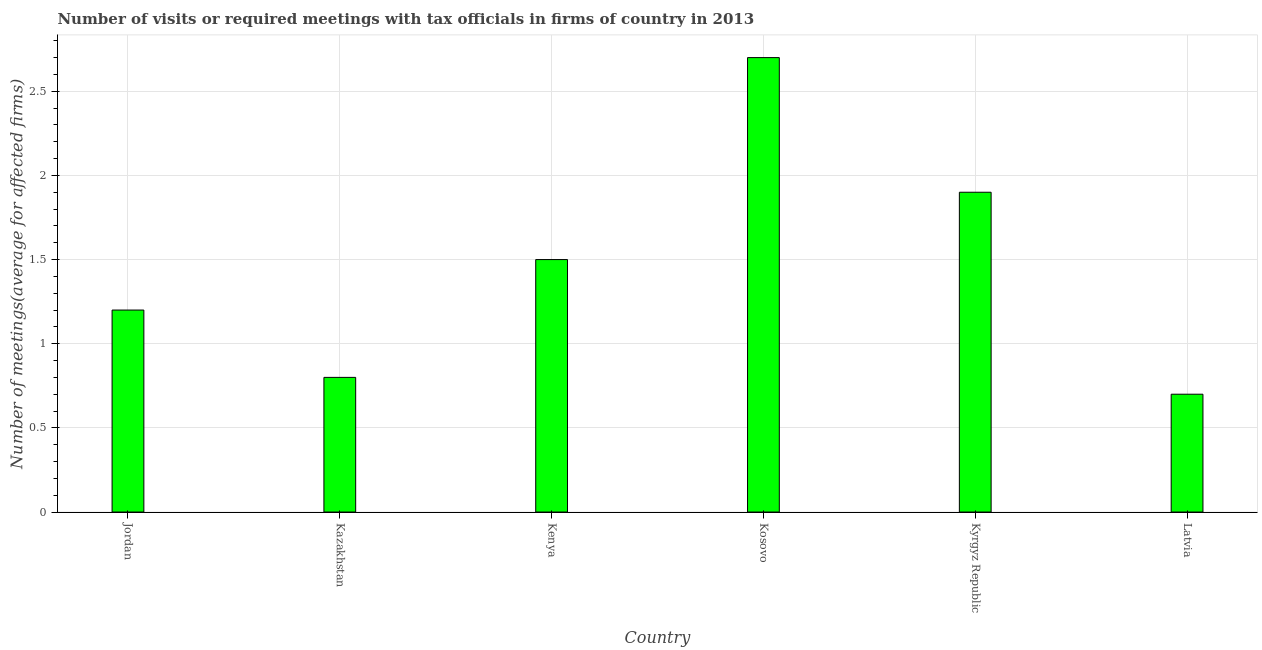Does the graph contain any zero values?
Offer a terse response. No. What is the title of the graph?
Make the answer very short. Number of visits or required meetings with tax officials in firms of country in 2013. What is the label or title of the Y-axis?
Provide a succinct answer. Number of meetings(average for affected firms). Across all countries, what is the maximum number of required meetings with tax officials?
Your answer should be very brief. 2.7. In which country was the number of required meetings with tax officials maximum?
Make the answer very short. Kosovo. In which country was the number of required meetings with tax officials minimum?
Provide a succinct answer. Latvia. What is the sum of the number of required meetings with tax officials?
Offer a very short reply. 8.8. What is the average number of required meetings with tax officials per country?
Your answer should be compact. 1.47. What is the median number of required meetings with tax officials?
Your response must be concise. 1.35. In how many countries, is the number of required meetings with tax officials greater than 0.6 ?
Make the answer very short. 6. What is the ratio of the number of required meetings with tax officials in Kazakhstan to that in Kenya?
Give a very brief answer. 0.53. What is the difference between the highest and the second highest number of required meetings with tax officials?
Provide a succinct answer. 0.8. What is the difference between the highest and the lowest number of required meetings with tax officials?
Your response must be concise. 2. Are all the bars in the graph horizontal?
Your answer should be compact. No. What is the difference between two consecutive major ticks on the Y-axis?
Offer a very short reply. 0.5. Are the values on the major ticks of Y-axis written in scientific E-notation?
Keep it short and to the point. No. What is the Number of meetings(average for affected firms) of Jordan?
Offer a terse response. 1.2. What is the Number of meetings(average for affected firms) of Kazakhstan?
Offer a terse response. 0.8. What is the Number of meetings(average for affected firms) in Kenya?
Your response must be concise. 1.5. What is the Number of meetings(average for affected firms) of Kosovo?
Your answer should be compact. 2.7. What is the Number of meetings(average for affected firms) in Kyrgyz Republic?
Offer a terse response. 1.9. What is the difference between the Number of meetings(average for affected firms) in Jordan and Kenya?
Your response must be concise. -0.3. What is the difference between the Number of meetings(average for affected firms) in Kazakhstan and Kyrgyz Republic?
Provide a short and direct response. -1.1. What is the difference between the Number of meetings(average for affected firms) in Kazakhstan and Latvia?
Your answer should be compact. 0.1. What is the difference between the Number of meetings(average for affected firms) in Kenya and Kosovo?
Ensure brevity in your answer.  -1.2. What is the difference between the Number of meetings(average for affected firms) in Kenya and Kyrgyz Republic?
Your answer should be compact. -0.4. What is the difference between the Number of meetings(average for affected firms) in Kenya and Latvia?
Your response must be concise. 0.8. What is the difference between the Number of meetings(average for affected firms) in Kosovo and Latvia?
Your answer should be compact. 2. What is the ratio of the Number of meetings(average for affected firms) in Jordan to that in Kenya?
Offer a very short reply. 0.8. What is the ratio of the Number of meetings(average for affected firms) in Jordan to that in Kosovo?
Provide a short and direct response. 0.44. What is the ratio of the Number of meetings(average for affected firms) in Jordan to that in Kyrgyz Republic?
Make the answer very short. 0.63. What is the ratio of the Number of meetings(average for affected firms) in Jordan to that in Latvia?
Your answer should be compact. 1.71. What is the ratio of the Number of meetings(average for affected firms) in Kazakhstan to that in Kenya?
Ensure brevity in your answer.  0.53. What is the ratio of the Number of meetings(average for affected firms) in Kazakhstan to that in Kosovo?
Offer a terse response. 0.3. What is the ratio of the Number of meetings(average for affected firms) in Kazakhstan to that in Kyrgyz Republic?
Ensure brevity in your answer.  0.42. What is the ratio of the Number of meetings(average for affected firms) in Kazakhstan to that in Latvia?
Make the answer very short. 1.14. What is the ratio of the Number of meetings(average for affected firms) in Kenya to that in Kosovo?
Your answer should be compact. 0.56. What is the ratio of the Number of meetings(average for affected firms) in Kenya to that in Kyrgyz Republic?
Ensure brevity in your answer.  0.79. What is the ratio of the Number of meetings(average for affected firms) in Kenya to that in Latvia?
Your answer should be compact. 2.14. What is the ratio of the Number of meetings(average for affected firms) in Kosovo to that in Kyrgyz Republic?
Provide a succinct answer. 1.42. What is the ratio of the Number of meetings(average for affected firms) in Kosovo to that in Latvia?
Give a very brief answer. 3.86. What is the ratio of the Number of meetings(average for affected firms) in Kyrgyz Republic to that in Latvia?
Your response must be concise. 2.71. 